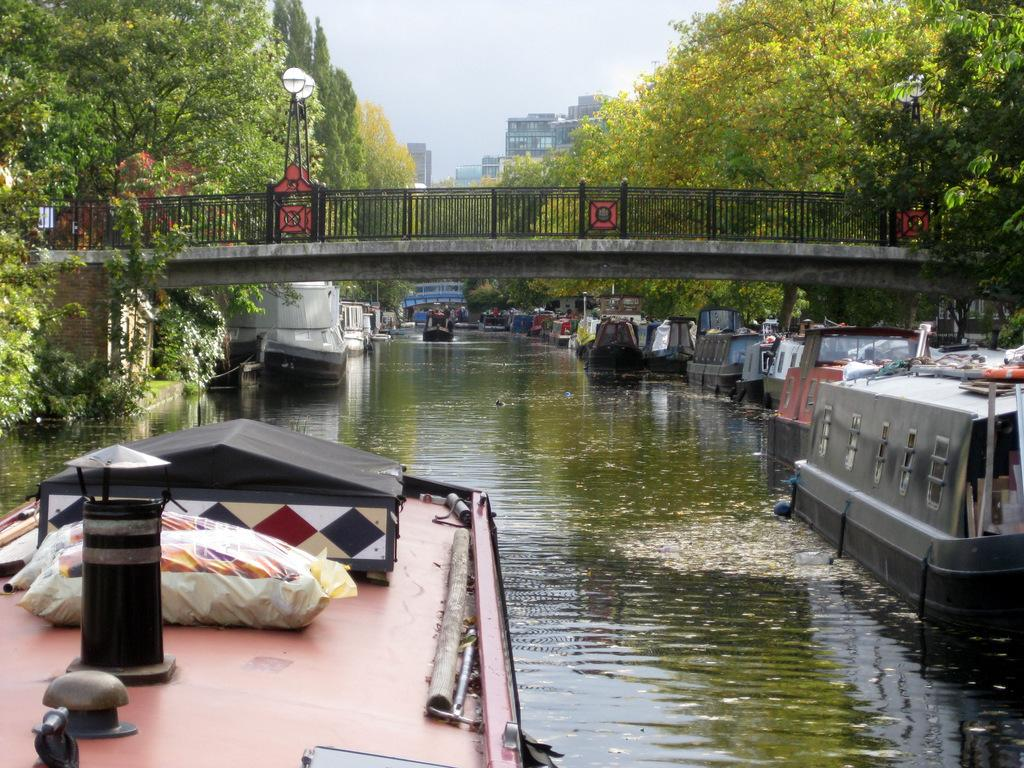What is on the water in the image? There are boats on the water in the image. What structure can be seen crossing over the water? There is a bridge in the image. What type of vegetation is present in the image? There are trees in the image. What type of man-made structures can be seen in the image? There are buildings in the image. What can be seen in the background of the image? The sky is visible in the background of the image. Can you see any rats on the bridge in the image? There are no rats present in the image. Is there any smoke coming from the boats in the image? There is no smoke visible in the image. 